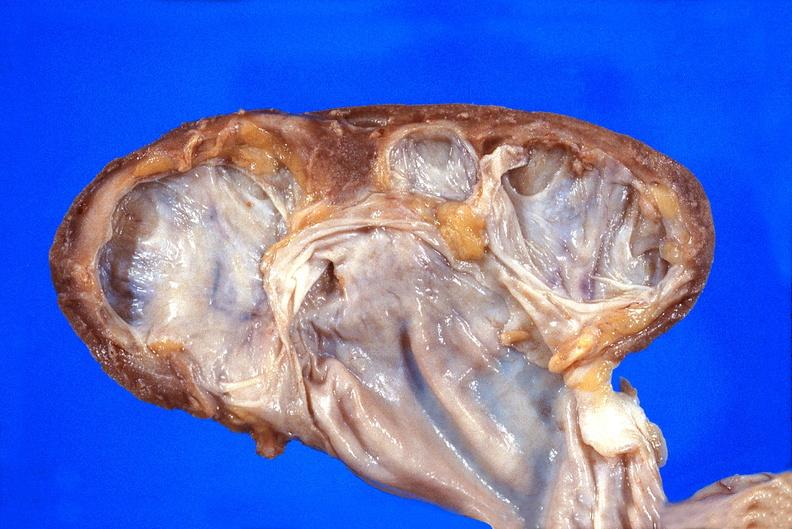what does this image show?
Answer the question using a single word or phrase. Kidney 